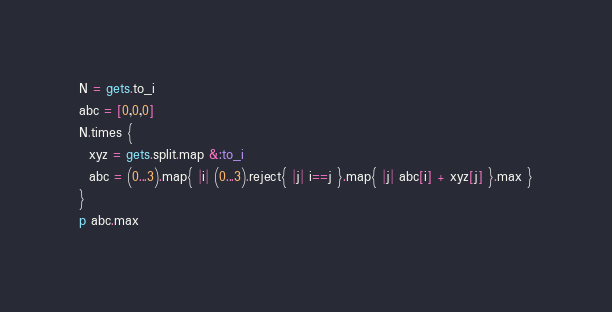<code> <loc_0><loc_0><loc_500><loc_500><_Ruby_>N = gets.to_i
abc = [0,0,0]
N.times {
  xyz = gets.split.map &:to_i
  abc = (0...3).map{ |i| (0...3).reject{ |j| i==j }.map{ |j| abc[i] + xyz[j] }.max }
}
p abc.max
</code> 